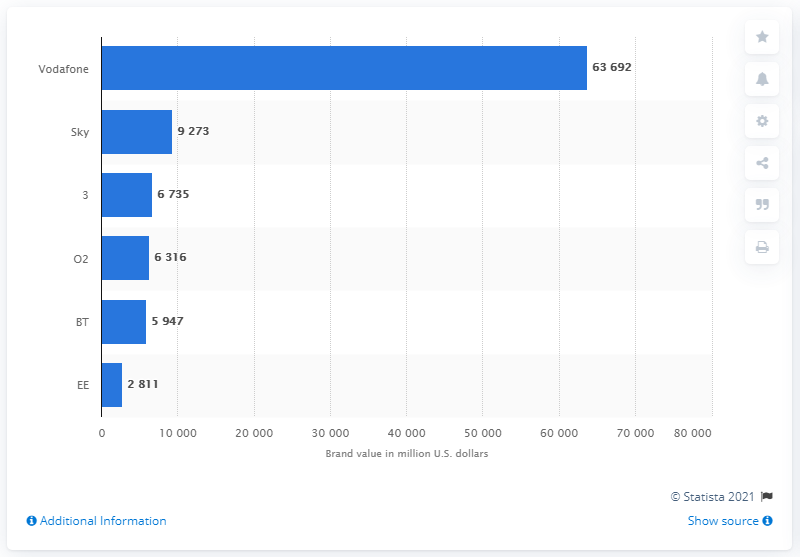Indicate a few pertinent items in this graphic. As of 2021, the brand value of Vodafone in US dollars was approximately 63,692. The value of Vodafone in 2020 was 63,692. The average value of telecommunication brands between BT and EE is 4379. O2's brand value was 6,316. 